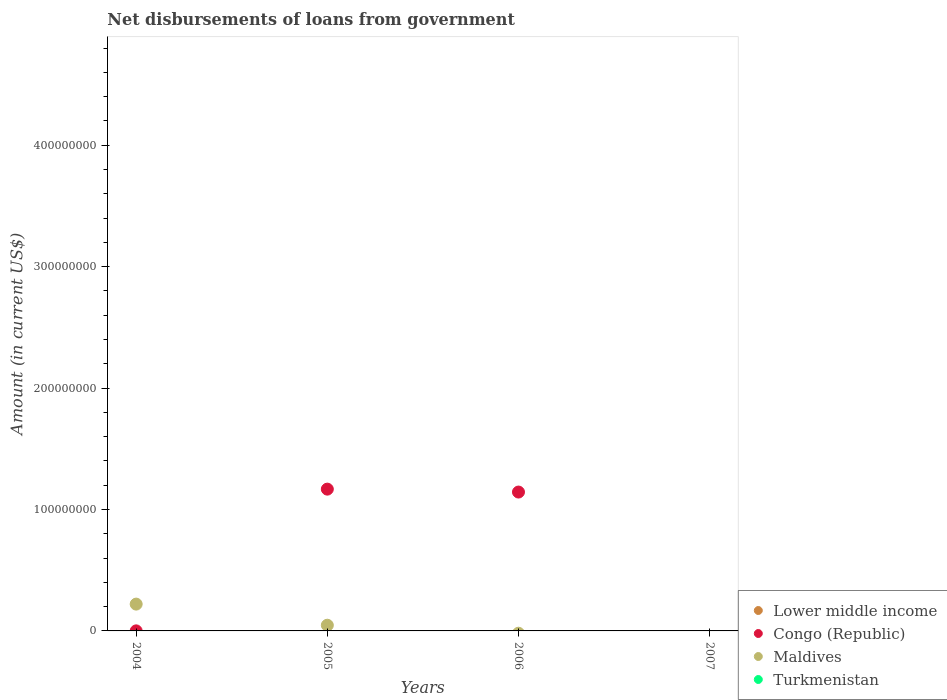Across all years, what is the maximum amount of loan disbursed from government in Congo (Republic)?
Make the answer very short. 1.17e+08. In which year was the amount of loan disbursed from government in Congo (Republic) maximum?
Give a very brief answer. 2005. What is the total amount of loan disbursed from government in Congo (Republic) in the graph?
Your response must be concise. 2.31e+08. What is the difference between the amount of loan disbursed from government in Congo (Republic) in 2004 and that in 2006?
Ensure brevity in your answer.  -1.14e+08. What is the difference between the amount of loan disbursed from government in Maldives in 2006 and the amount of loan disbursed from government in Congo (Republic) in 2005?
Your answer should be compact. -1.17e+08. What is the average amount of loan disbursed from government in Congo (Republic) per year?
Your answer should be compact. 5.78e+07. What is the ratio of the amount of loan disbursed from government in Congo (Republic) in 2004 to that in 2006?
Offer a very short reply. 0. What is the difference between the highest and the second highest amount of loan disbursed from government in Congo (Republic)?
Your answer should be compact. 2.40e+06. What is the difference between the highest and the lowest amount of loan disbursed from government in Congo (Republic)?
Your answer should be very brief. 1.17e+08. In how many years, is the amount of loan disbursed from government in Congo (Republic) greater than the average amount of loan disbursed from government in Congo (Republic) taken over all years?
Keep it short and to the point. 2. Is the sum of the amount of loan disbursed from government in Congo (Republic) in 2004 and 2005 greater than the maximum amount of loan disbursed from government in Turkmenistan across all years?
Give a very brief answer. Yes. Is the amount of loan disbursed from government in Lower middle income strictly less than the amount of loan disbursed from government in Turkmenistan over the years?
Make the answer very short. Yes. How many dotlines are there?
Make the answer very short. 2. How many years are there in the graph?
Ensure brevity in your answer.  4. What is the difference between two consecutive major ticks on the Y-axis?
Provide a short and direct response. 1.00e+08. Are the values on the major ticks of Y-axis written in scientific E-notation?
Make the answer very short. No. Does the graph contain any zero values?
Your response must be concise. Yes. Does the graph contain grids?
Your answer should be very brief. No. Where does the legend appear in the graph?
Provide a succinct answer. Bottom right. How many legend labels are there?
Make the answer very short. 4. How are the legend labels stacked?
Offer a very short reply. Vertical. What is the title of the graph?
Your response must be concise. Net disbursements of loans from government. What is the label or title of the X-axis?
Your answer should be compact. Years. What is the Amount (in current US$) in Congo (Republic) in 2004?
Your answer should be very brief. 4.60e+04. What is the Amount (in current US$) of Maldives in 2004?
Give a very brief answer. 2.21e+07. What is the Amount (in current US$) in Congo (Republic) in 2005?
Your answer should be very brief. 1.17e+08. What is the Amount (in current US$) in Maldives in 2005?
Provide a short and direct response. 4.68e+06. What is the Amount (in current US$) of Turkmenistan in 2005?
Offer a very short reply. 0. What is the Amount (in current US$) of Lower middle income in 2006?
Make the answer very short. 0. What is the Amount (in current US$) in Congo (Republic) in 2006?
Give a very brief answer. 1.14e+08. What is the Amount (in current US$) in Maldives in 2006?
Keep it short and to the point. 0. What is the Amount (in current US$) in Turkmenistan in 2006?
Keep it short and to the point. 0. What is the Amount (in current US$) of Lower middle income in 2007?
Provide a short and direct response. 0. What is the Amount (in current US$) of Maldives in 2007?
Ensure brevity in your answer.  0. What is the Amount (in current US$) in Turkmenistan in 2007?
Make the answer very short. 0. Across all years, what is the maximum Amount (in current US$) of Congo (Republic)?
Provide a succinct answer. 1.17e+08. Across all years, what is the maximum Amount (in current US$) of Maldives?
Your answer should be compact. 2.21e+07. Across all years, what is the minimum Amount (in current US$) of Congo (Republic)?
Give a very brief answer. 0. What is the total Amount (in current US$) of Lower middle income in the graph?
Provide a short and direct response. 0. What is the total Amount (in current US$) of Congo (Republic) in the graph?
Provide a short and direct response. 2.31e+08. What is the total Amount (in current US$) in Maldives in the graph?
Offer a terse response. 2.68e+07. What is the total Amount (in current US$) in Turkmenistan in the graph?
Give a very brief answer. 0. What is the difference between the Amount (in current US$) in Congo (Republic) in 2004 and that in 2005?
Give a very brief answer. -1.17e+08. What is the difference between the Amount (in current US$) in Maldives in 2004 and that in 2005?
Offer a very short reply. 1.74e+07. What is the difference between the Amount (in current US$) of Congo (Republic) in 2004 and that in 2006?
Provide a short and direct response. -1.14e+08. What is the difference between the Amount (in current US$) of Congo (Republic) in 2005 and that in 2006?
Keep it short and to the point. 2.40e+06. What is the difference between the Amount (in current US$) of Congo (Republic) in 2004 and the Amount (in current US$) of Maldives in 2005?
Give a very brief answer. -4.64e+06. What is the average Amount (in current US$) of Lower middle income per year?
Offer a very short reply. 0. What is the average Amount (in current US$) of Congo (Republic) per year?
Your answer should be compact. 5.78e+07. What is the average Amount (in current US$) in Maldives per year?
Your response must be concise. 6.69e+06. What is the average Amount (in current US$) in Turkmenistan per year?
Give a very brief answer. 0. In the year 2004, what is the difference between the Amount (in current US$) of Congo (Republic) and Amount (in current US$) of Maldives?
Keep it short and to the point. -2.20e+07. In the year 2005, what is the difference between the Amount (in current US$) in Congo (Republic) and Amount (in current US$) in Maldives?
Your response must be concise. 1.12e+08. What is the ratio of the Amount (in current US$) in Congo (Republic) in 2004 to that in 2005?
Offer a very short reply. 0. What is the ratio of the Amount (in current US$) of Maldives in 2004 to that in 2005?
Offer a terse response. 4.71. What is the ratio of the Amount (in current US$) of Congo (Republic) in 2004 to that in 2006?
Offer a very short reply. 0. What is the difference between the highest and the second highest Amount (in current US$) in Congo (Republic)?
Your answer should be compact. 2.40e+06. What is the difference between the highest and the lowest Amount (in current US$) of Congo (Republic)?
Your answer should be very brief. 1.17e+08. What is the difference between the highest and the lowest Amount (in current US$) in Maldives?
Your answer should be compact. 2.21e+07. 